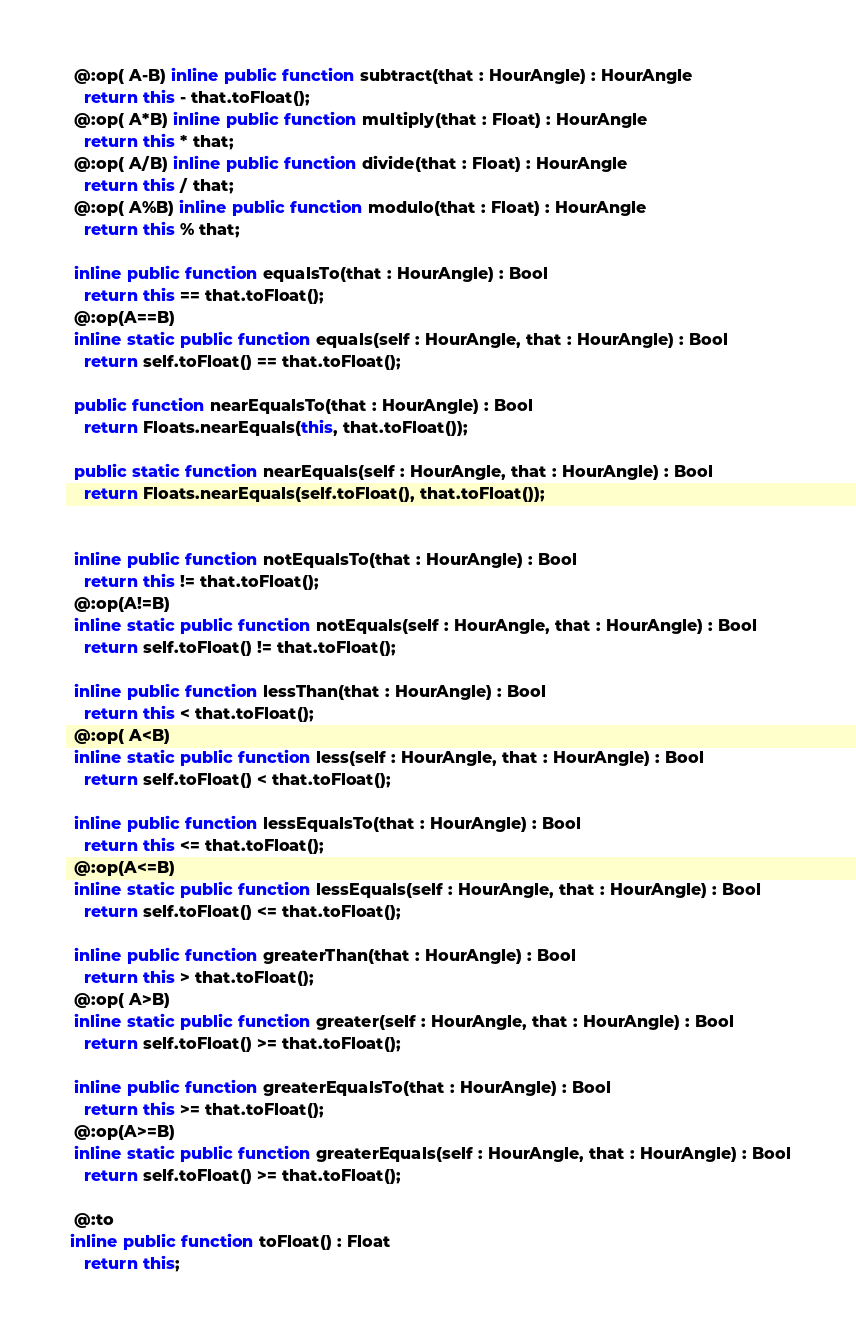<code> <loc_0><loc_0><loc_500><loc_500><_Haxe_>  @:op( A-B) inline public function subtract(that : HourAngle) : HourAngle
    return this - that.toFloat();
  @:op( A*B) inline public function multiply(that : Float) : HourAngle
    return this * that;
  @:op( A/B) inline public function divide(that : Float) : HourAngle
    return this / that;
  @:op( A%B) inline public function modulo(that : Float) : HourAngle
    return this % that;

  inline public function equalsTo(that : HourAngle) : Bool
    return this == that.toFloat();
  @:op(A==B)
  inline static public function equals(self : HourAngle, that : HourAngle) : Bool
    return self.toFloat() == that.toFloat();

  public function nearEqualsTo(that : HourAngle) : Bool 
    return Floats.nearEquals(this, that.toFloat());
  
  public static function nearEquals(self : HourAngle, that : HourAngle) : Bool 
    return Floats.nearEquals(self.toFloat(), that.toFloat());
  

  inline public function notEqualsTo(that : HourAngle) : Bool
    return this != that.toFloat();
  @:op(A!=B)
  inline static public function notEquals(self : HourAngle, that : HourAngle) : Bool
    return self.toFloat() != that.toFloat();

  inline public function lessThan(that : HourAngle) : Bool
    return this < that.toFloat();
  @:op( A<B)
  inline static public function less(self : HourAngle, that : HourAngle) : Bool
    return self.toFloat() < that.toFloat();

  inline public function lessEqualsTo(that : HourAngle) : Bool
    return this <= that.toFloat();
  @:op(A<=B)
  inline static public function lessEquals(self : HourAngle, that : HourAngle) : Bool
    return self.toFloat() <= that.toFloat();

  inline public function greaterThan(that : HourAngle) : Bool
    return this > that.toFloat();
  @:op( A>B)
  inline static public function greater(self : HourAngle, that : HourAngle) : Bool
    return self.toFloat() >= that.toFloat();

  inline public function greaterEqualsTo(that : HourAngle) : Bool
    return this >= that.toFloat();
  @:op(A>=B)
  inline static public function greaterEquals(self : HourAngle, that : HourAngle) : Bool
    return self.toFloat() >= that.toFloat();

  @:to
 inline public function toFloat() : Float
    return this;

</code> 